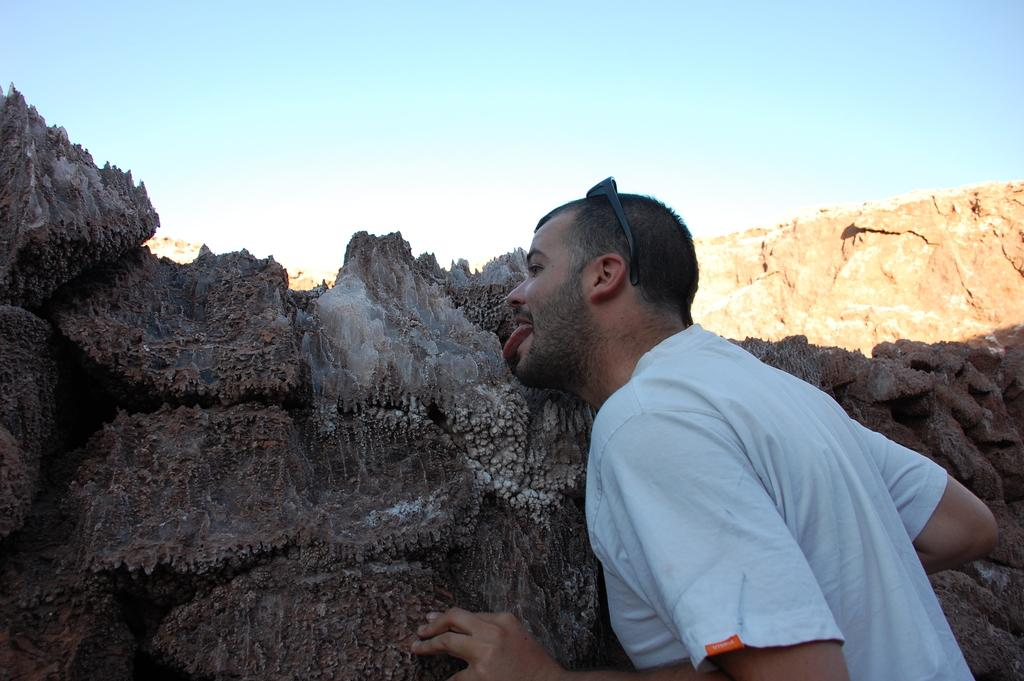Who or what is the main subject in the image? There is a person in the image. What is the person doing in the image? The person is licking rocks. What can be seen in the background of the image? There is a mountain and the sky visible in the background of the image. What type of payment is being made for the quartz in the image? There is no quartz or payment present in the image. The person is simply licking rocks. 